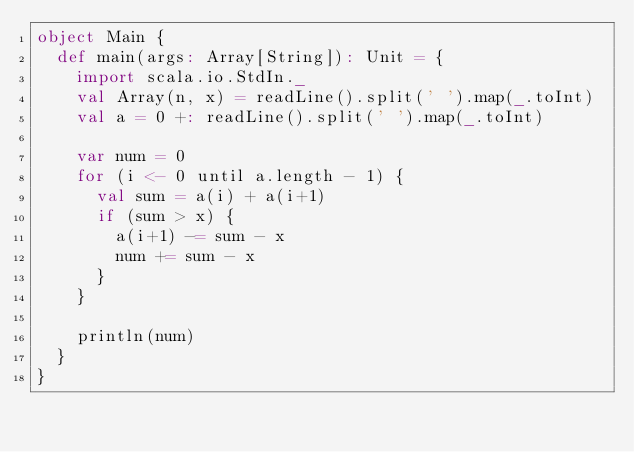<code> <loc_0><loc_0><loc_500><loc_500><_Scala_>object Main {
  def main(args: Array[String]): Unit = {
    import scala.io.StdIn._
    val Array(n, x) = readLine().split(' ').map(_.toInt)
    val a = 0 +: readLine().split(' ').map(_.toInt)

    var num = 0
    for (i <- 0 until a.length - 1) {
      val sum = a(i) + a(i+1)
      if (sum > x) {
        a(i+1) -= sum - x
        num += sum - x
      }
    }

    println(num)
  }
}
</code> 